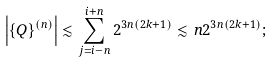<formula> <loc_0><loc_0><loc_500><loc_500>\left | \{ Q \} ^ { ( n ) } \right | \lesssim \sum _ { j = i - n } ^ { i + n } 2 ^ { 3 n ( 2 k + 1 ) } \lesssim n 2 ^ { 3 n ( 2 k + 1 ) } ;</formula> 